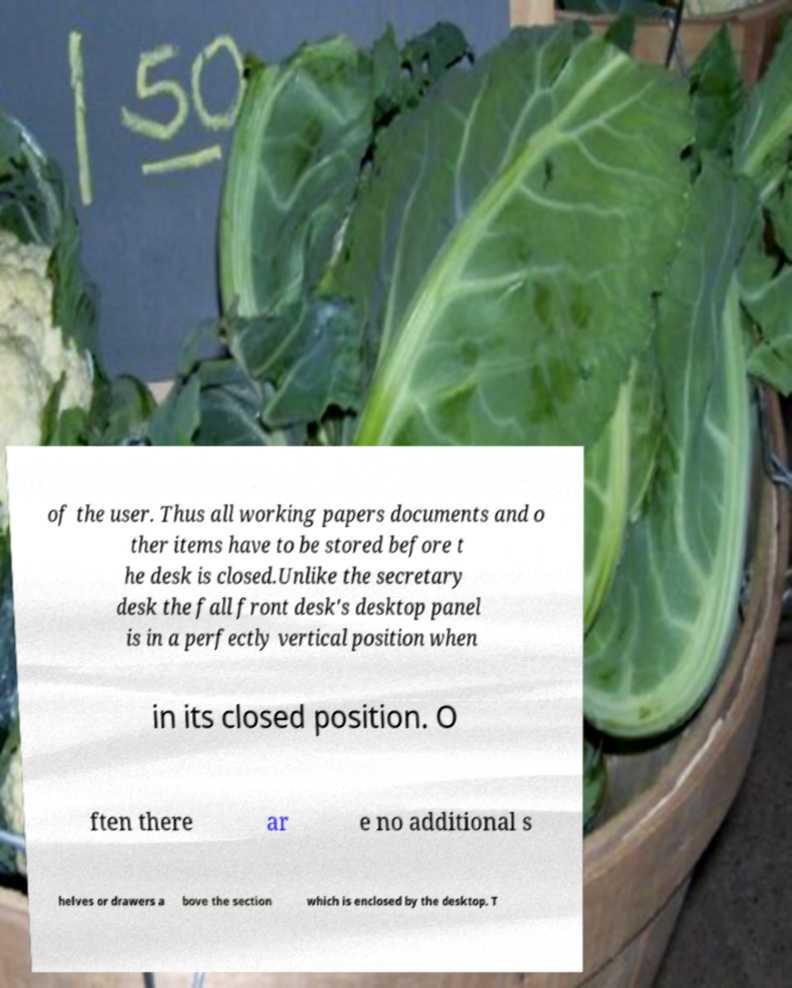I need the written content from this picture converted into text. Can you do that? of the user. Thus all working papers documents and o ther items have to be stored before t he desk is closed.Unlike the secretary desk the fall front desk's desktop panel is in a perfectly vertical position when in its closed position. O ften there ar e no additional s helves or drawers a bove the section which is enclosed by the desktop. T 